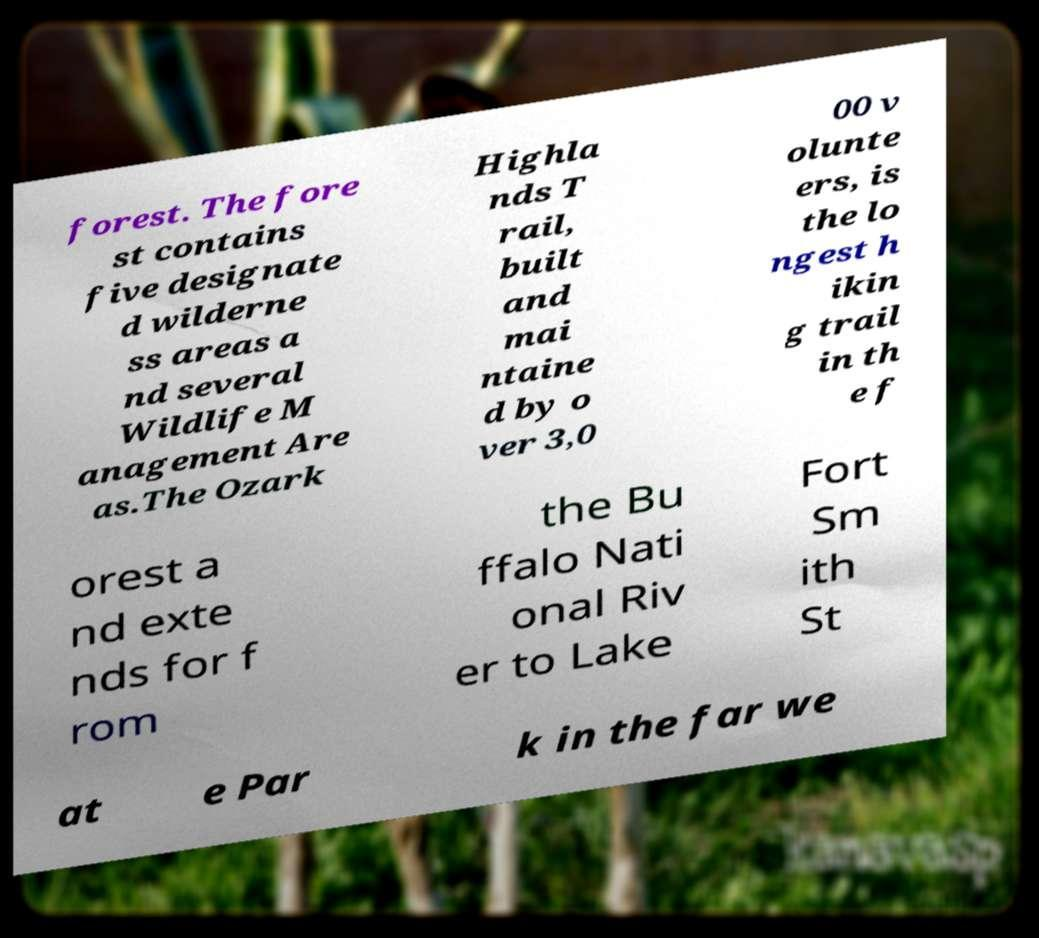Can you accurately transcribe the text from the provided image for me? forest. The fore st contains five designate d wilderne ss areas a nd several Wildlife M anagement Are as.The Ozark Highla nds T rail, built and mai ntaine d by o ver 3,0 00 v olunte ers, is the lo ngest h ikin g trail in th e f orest a nd exte nds for f rom the Bu ffalo Nati onal Riv er to Lake Fort Sm ith St at e Par k in the far we 